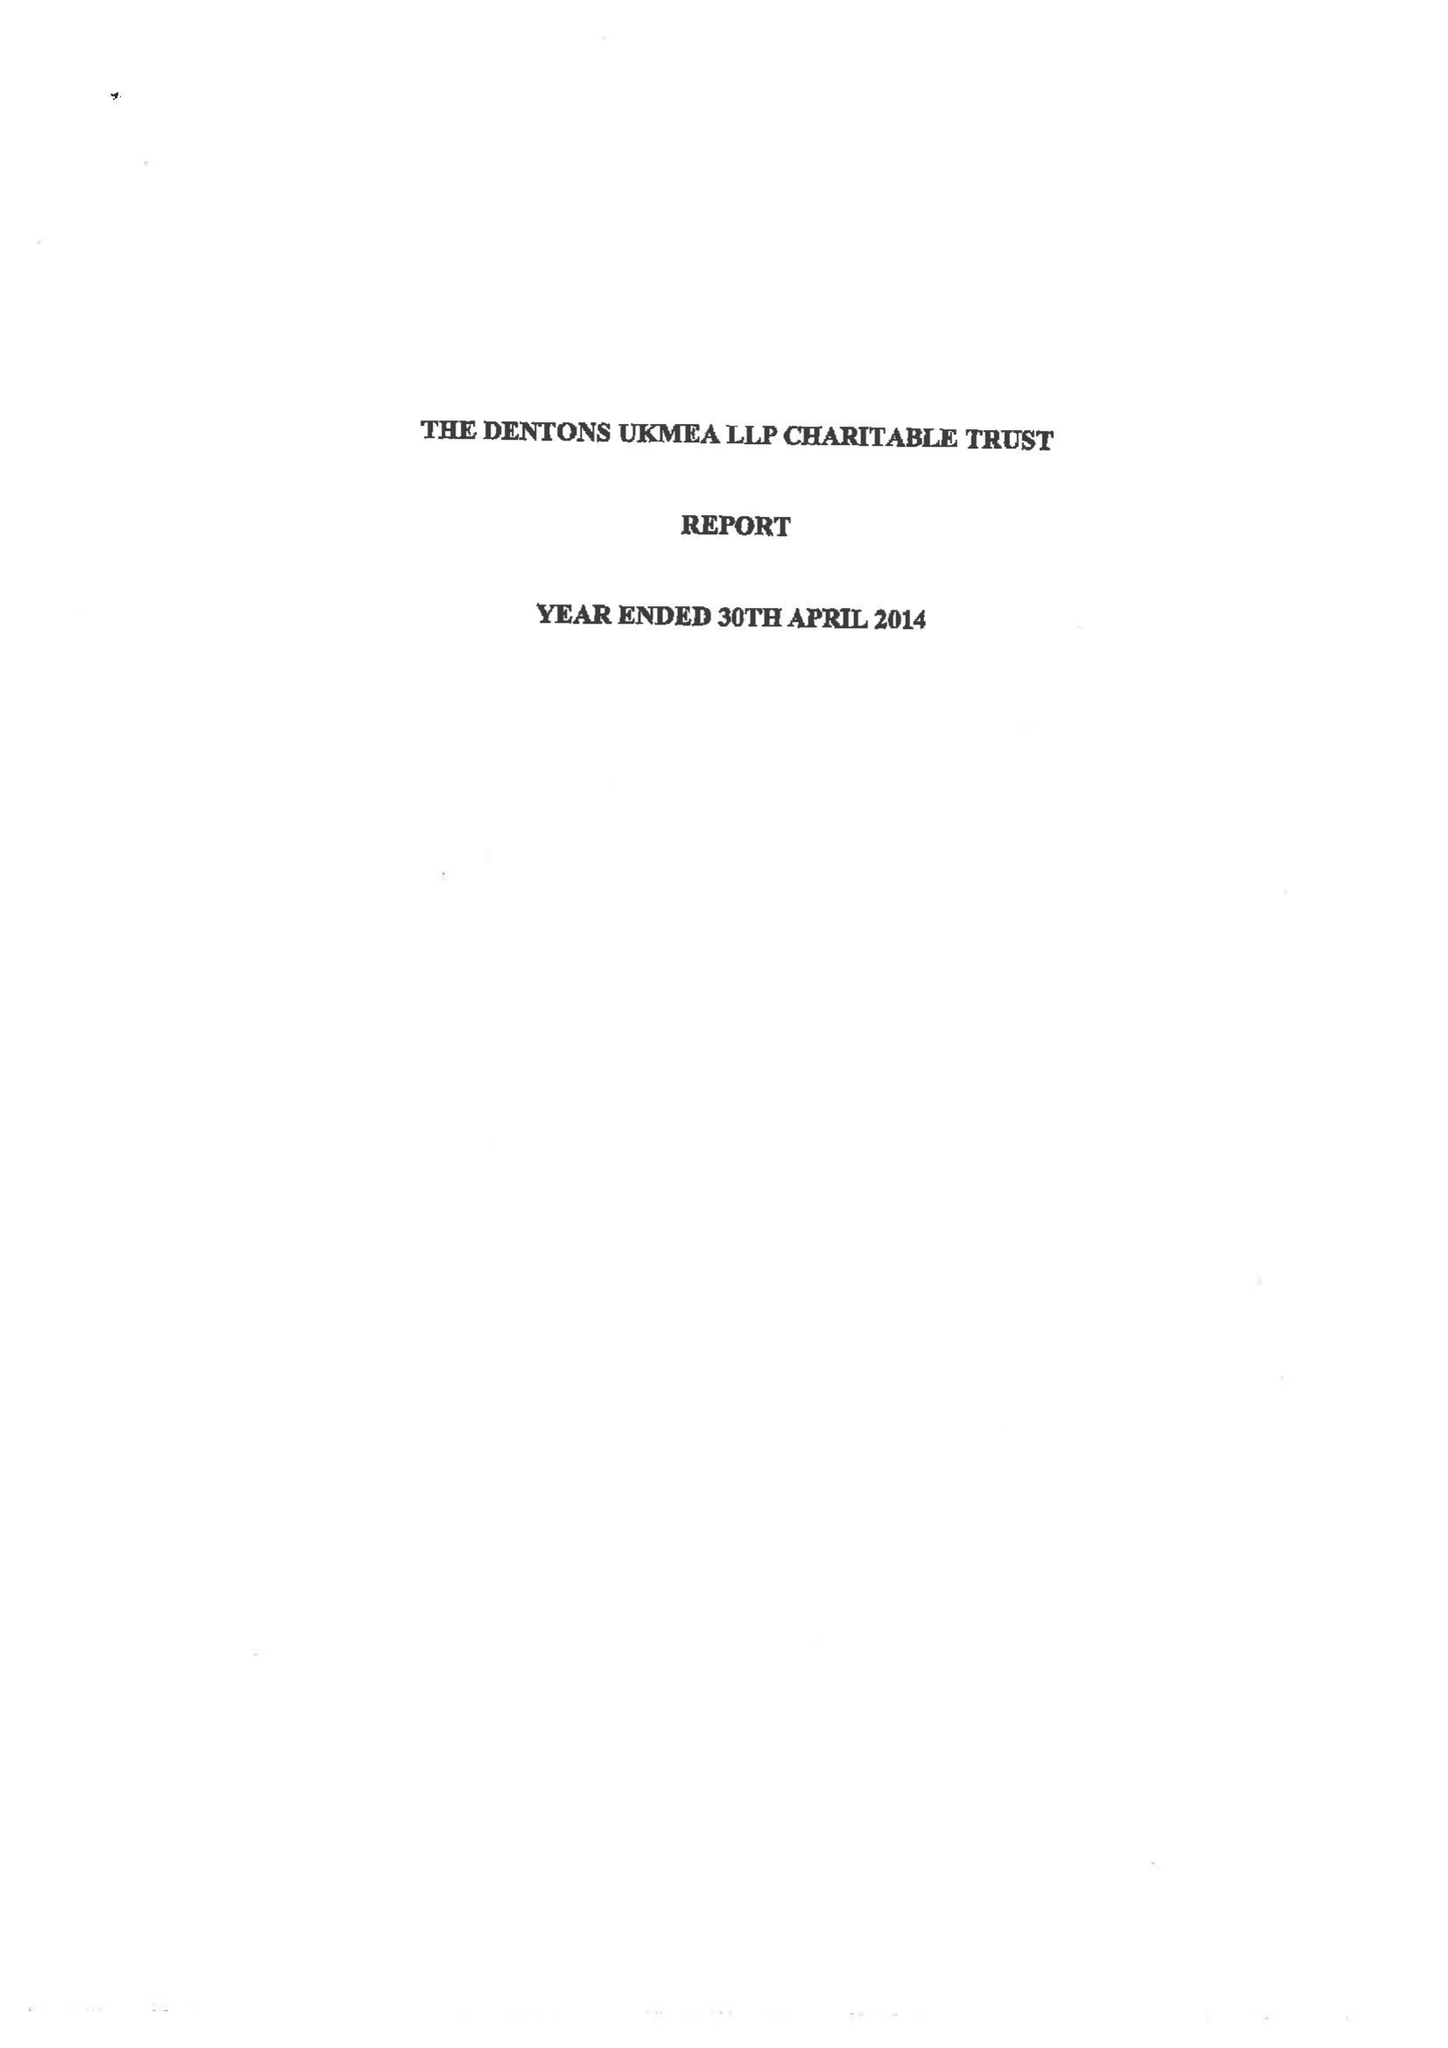What is the value for the report_date?
Answer the question using a single word or phrase. 2014-04-30 